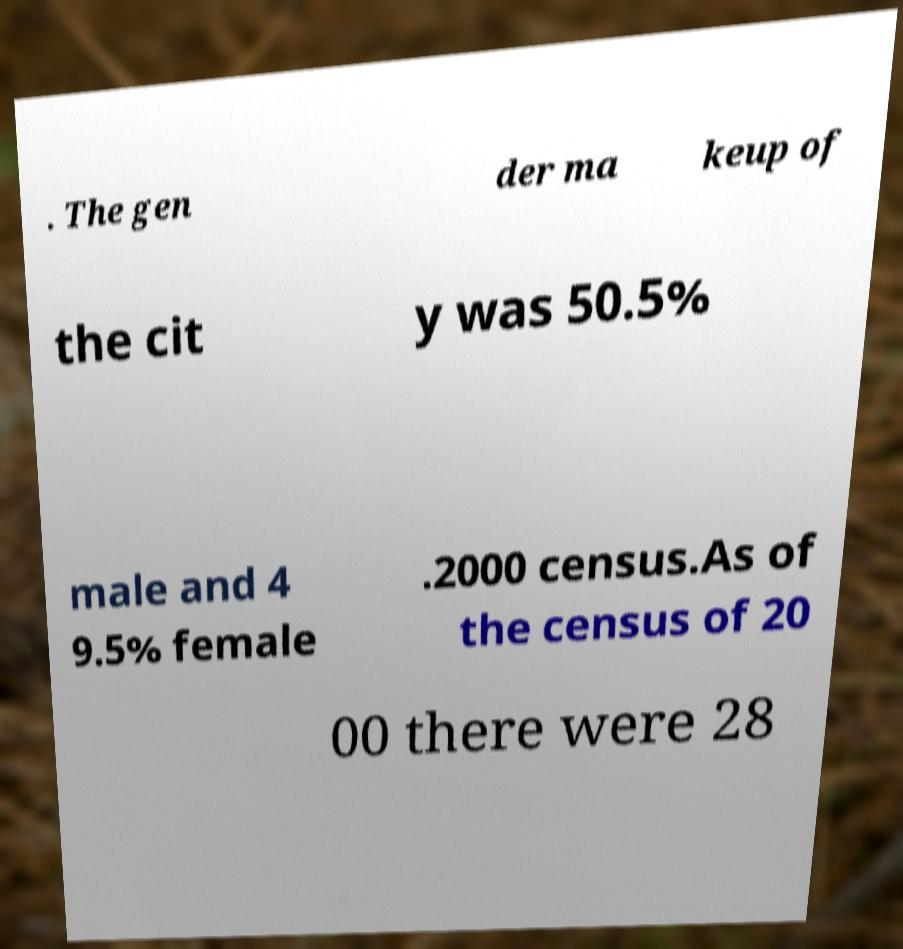Could you extract and type out the text from this image? . The gen der ma keup of the cit y was 50.5% male and 4 9.5% female .2000 census.As of the census of 20 00 there were 28 